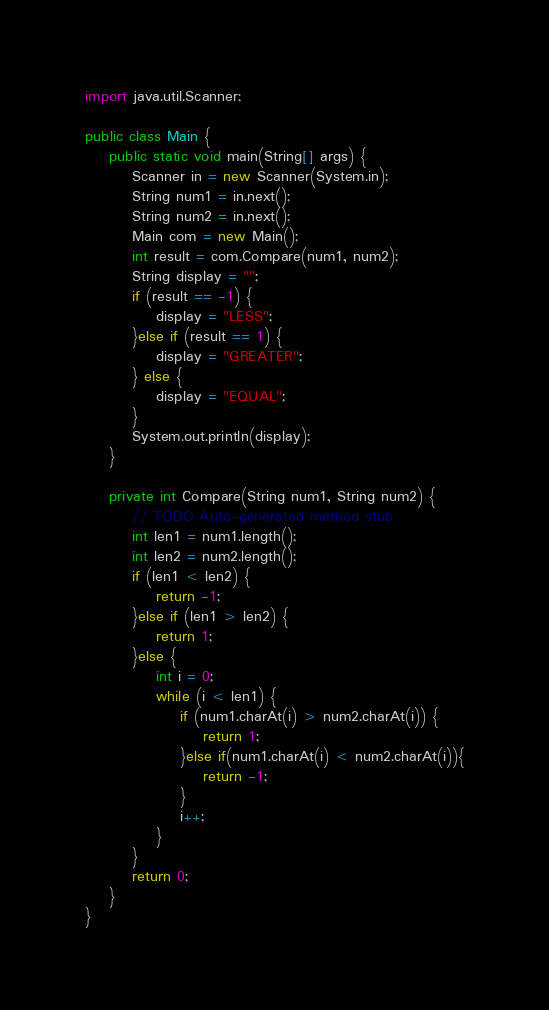Convert code to text. <code><loc_0><loc_0><loc_500><loc_500><_Java_>import java.util.Scanner;

public class Main {
	public static void main(String[] args) {
		Scanner in = new Scanner(System.in);
		String num1 = in.next();
		String num2 = in.next();
		Main com = new Main();
		int result = com.Compare(num1, num2);
		String display = "";
		if (result == -1) {
			display = "LESS";
		}else if (result == 1) {
			display = "GREATER";
		} else {
			display = "EQUAL";
		}
		System.out.println(display);
	}
	
	private int Compare(String num1, String num2) {
		// TODO Auto-generated method stub
		int len1 = num1.length();
		int len2 = num2.length();
		if (len1 < len2) {
			return -1;
		}else if (len1 > len2) {
			return 1;
		}else {
			int i = 0;
			while (i < len1) {
				if (num1.charAt(i) > num2.charAt(i)) {
					return 1;
				}else if(num1.charAt(i) < num2.charAt(i)){
					return -1;
				}
				i++;
			}
		}
		return 0;
	}
}</code> 